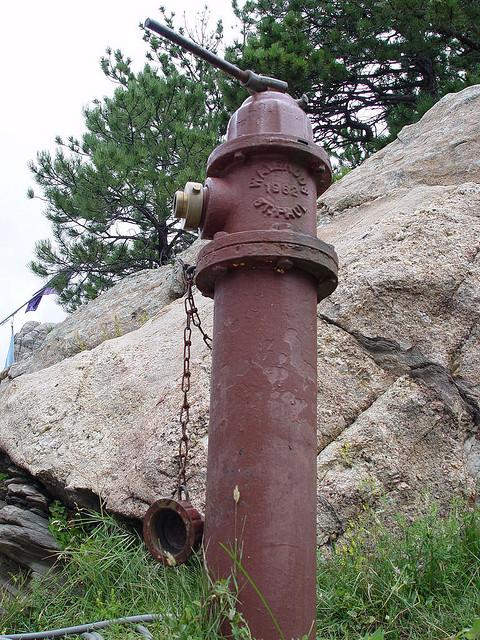How long ago has it been since the hydrant was manufactured?
Concise answer only. 1963. What color is the hydrant?
Short answer required. Red. Is the hydrant running?
Give a very brief answer. No. 